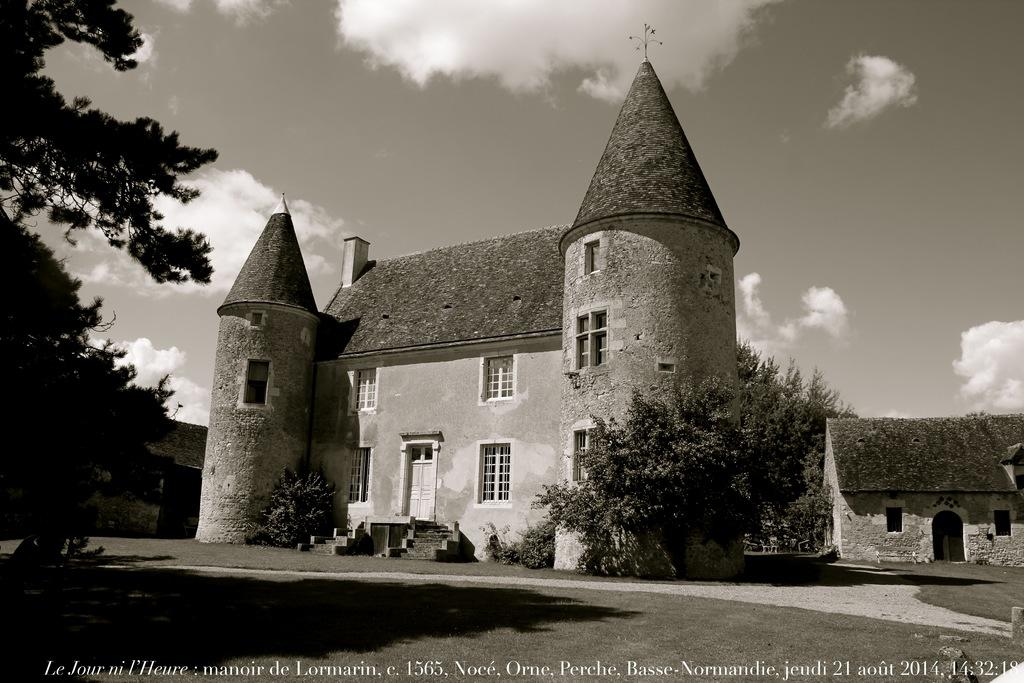What is the color scheme of the image? The image is black and white. What is located in the middle of the image? There is a building and trees in the middle of the image. What is visible at the top of the image? The sky is visible at the top of the image. What features can be seen on the building? There are doors and windows on the building. How many items are on the list in the image? There is no list present in the image. What is the chin of the person in the image? There is no person in the image, so there is no chin to describe. 